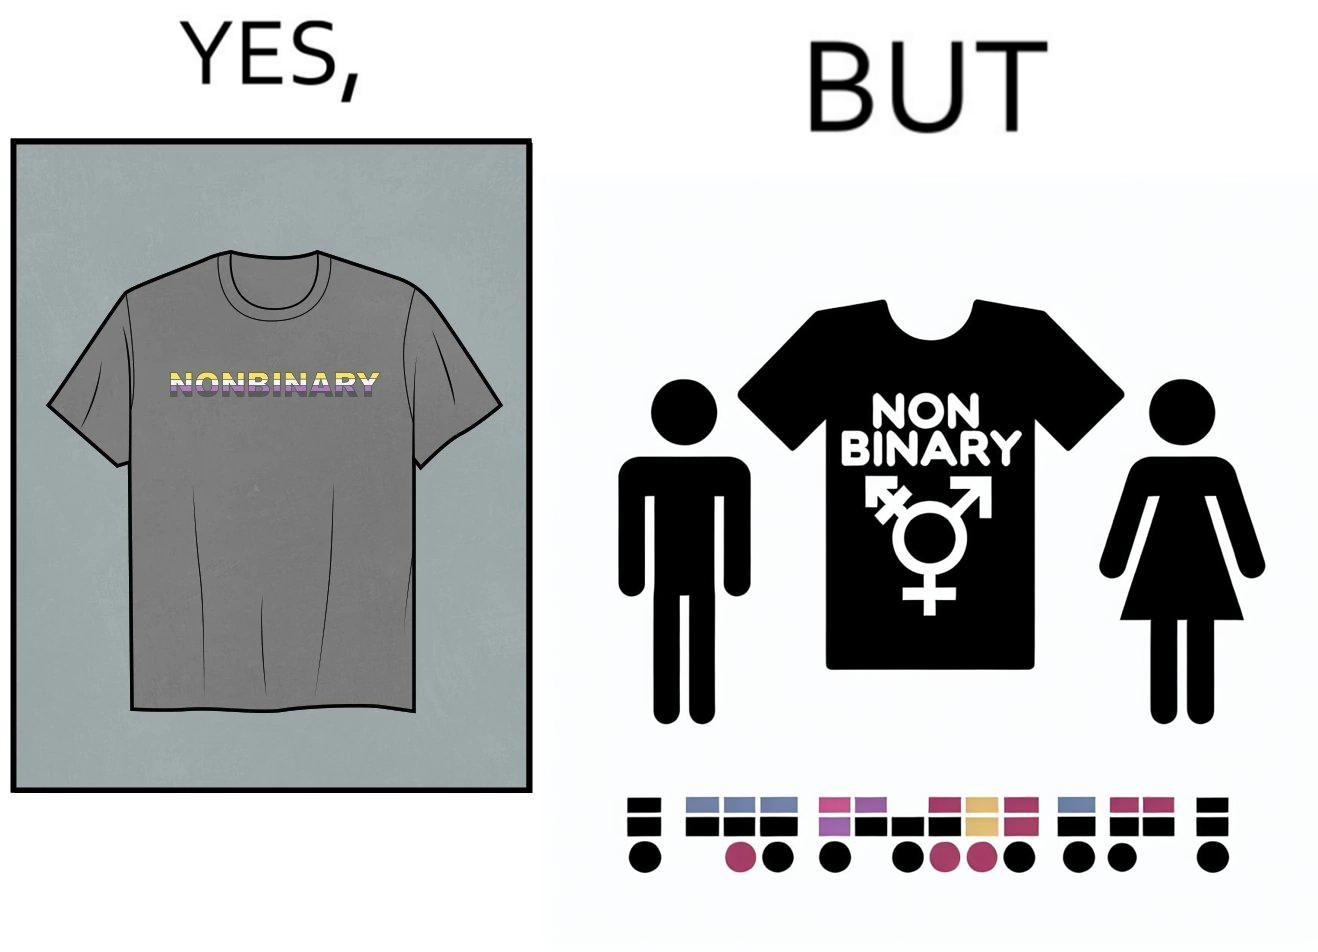What makes this image funny or satirical? The image is ironic, as the t-shirt that says "NONBINARY" has only 2 options for gender on an online retail forum. 